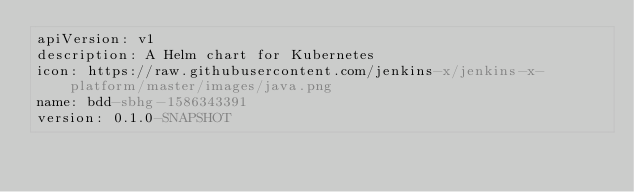Convert code to text. <code><loc_0><loc_0><loc_500><loc_500><_YAML_>apiVersion: v1
description: A Helm chart for Kubernetes
icon: https://raw.githubusercontent.com/jenkins-x/jenkins-x-platform/master/images/java.png
name: bdd-sbhg-1586343391
version: 0.1.0-SNAPSHOT
</code> 